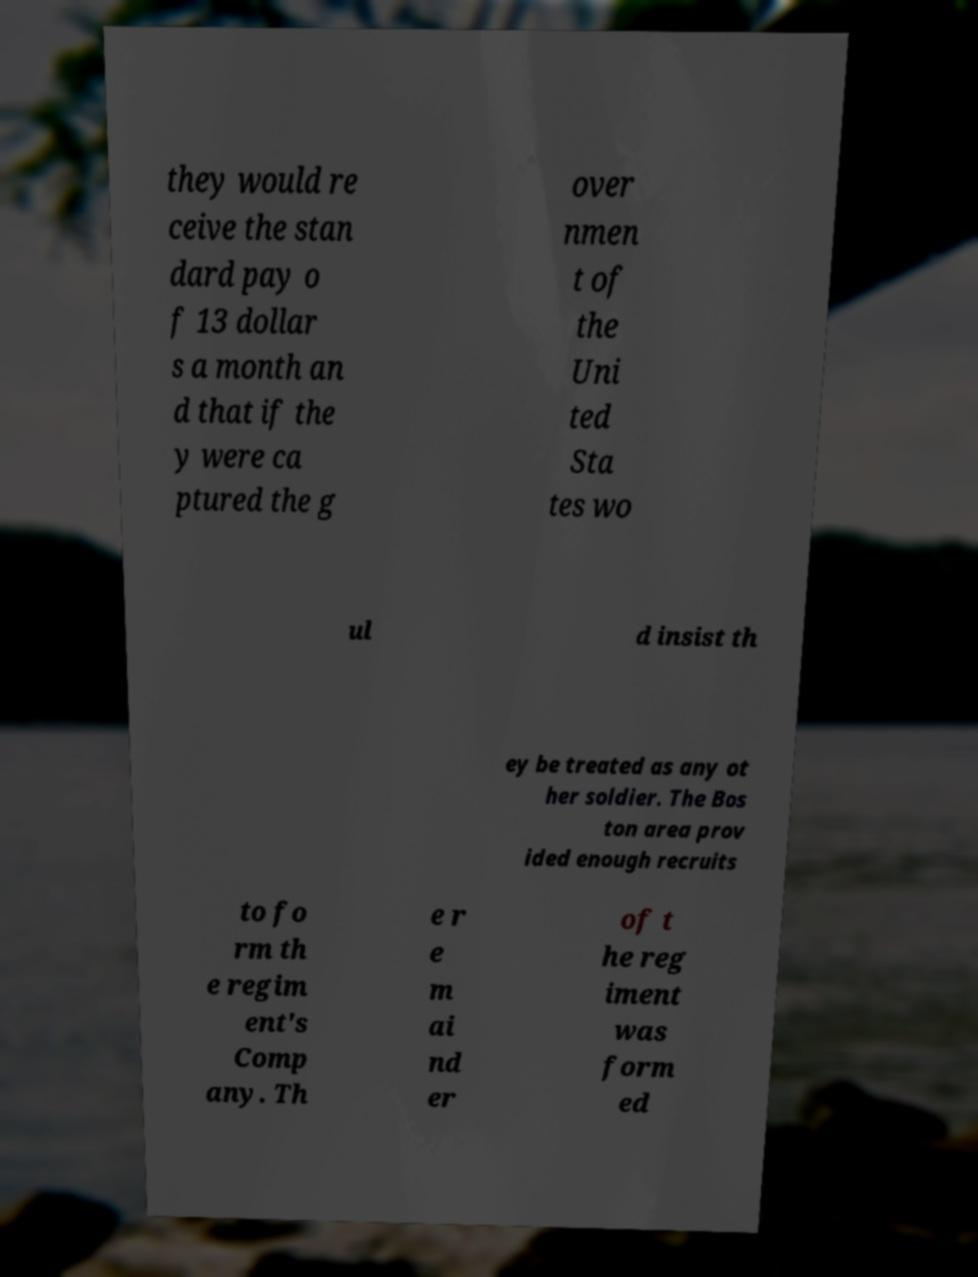I need the written content from this picture converted into text. Can you do that? they would re ceive the stan dard pay o f 13 dollar s a month an d that if the y were ca ptured the g over nmen t of the Uni ted Sta tes wo ul d insist th ey be treated as any ot her soldier. The Bos ton area prov ided enough recruits to fo rm th e regim ent's Comp any. Th e r e m ai nd er of t he reg iment was form ed 